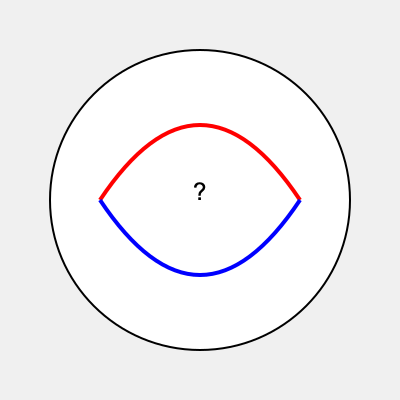Analyze the abstract artwork above. How might this image symbolize the concept of freedom of speech, and what philosophical implications does it suggest about the nature of expression in society? 1. Visual elements:
   - Circle: Represents unity, wholeness, or a global perspective
   - Red arc: Could symbolize passion, intensity, or restrictions
   - Blue arc: Might represent calmness, reason, or openness
   - Question mark: Indicates uncertainty or inquiry

2. Symbolic interpretation:
   - The circle encapsulates the entire composition, suggesting that freedom of speech exists within societal boundaries
   - The contrasting red and blue arcs create a yin-yang-like balance, implying the need for equilibrium in discourse
   - The arcs intersect at two points, potentially representing the meeting of diverse ideas or perspectives
   - The central question mark encourages critical thinking and questioning of established norms

3. Philosophical implications:
   - Duality of freedom: The artwork suggests that freedom of speech involves both passionate expression (red) and rational discourse (blue)
   - Boundaries of expression: The circular border implies that even in free societies, speech may have limits or consequences
   - Dialectical nature: The intersecting arcs suggest that truth or progress emerges from the clash of opposing viewpoints
   - Uncertainty and inquiry: The question mark emphasizes the role of continuous questioning in maintaining a free society

4. Societal reflection:
   - The image invites viewers to consider the complex nature of free speech in modern society
   - It challenges us to reflect on how we balance passionate beliefs with reasoned debate
   - The artwork suggests that freedom of speech is not a static concept but an ongoing negotiation

5. Poetic interpretation:
   - The composition could be seen as a metaphorical "eye" of society, observing and questioning itself
   - The flowing lines might represent the fluid nature of ideas and discourse in a free society
Answer: Balance between passion and reason within societal boundaries, emphasizing critical inquiry and dialectical progress. 